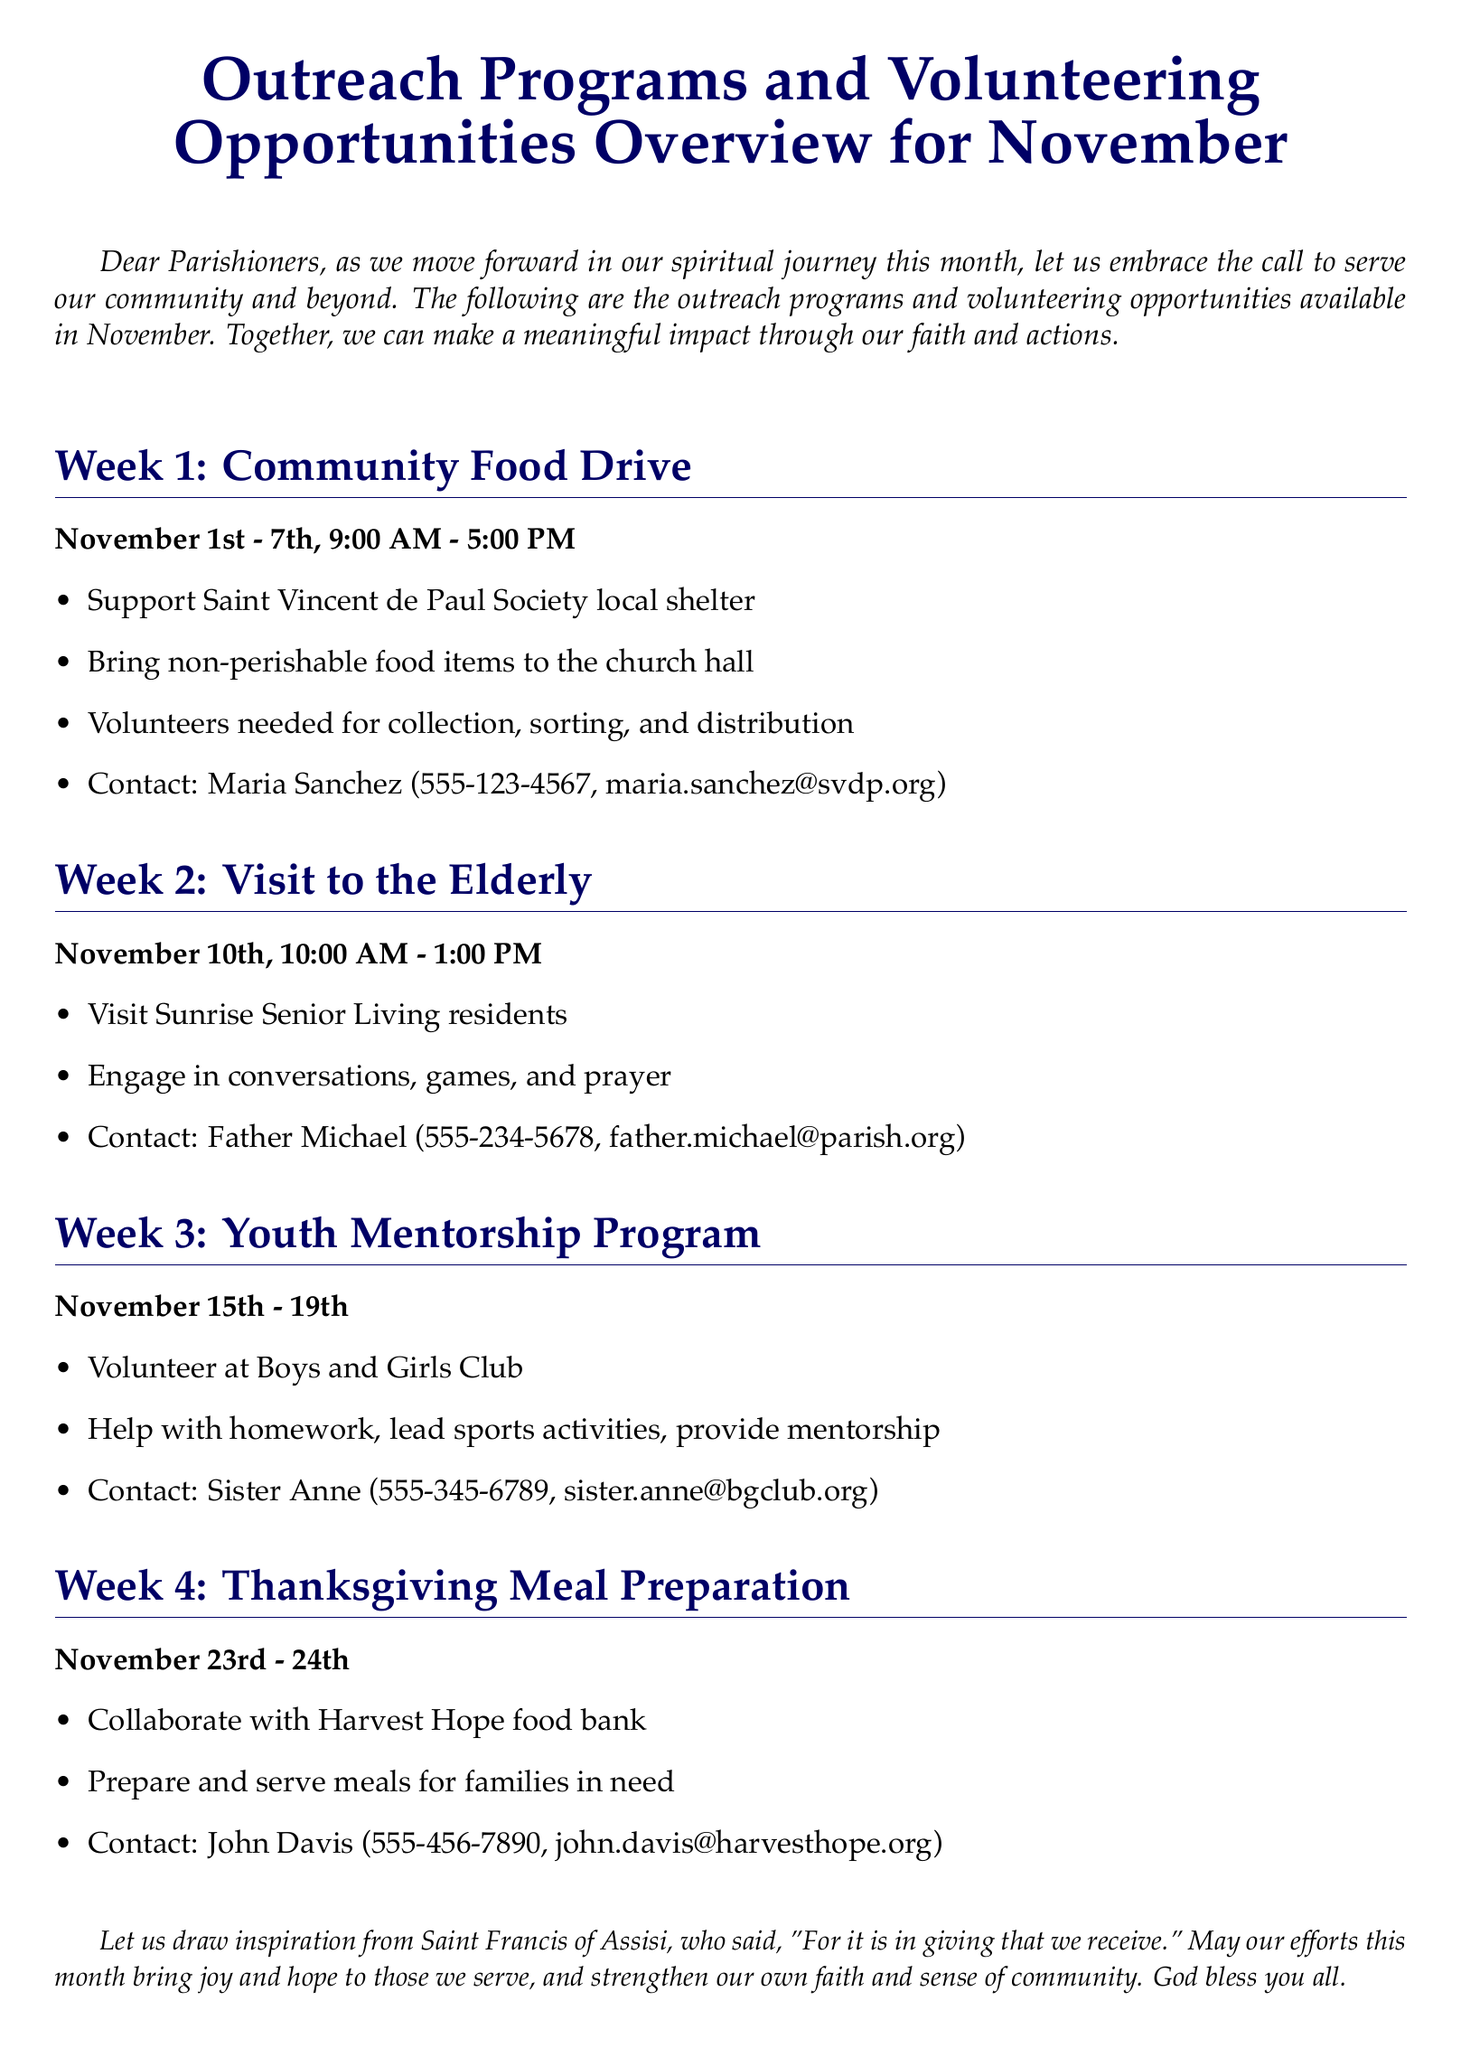What is the duration of the Community Food Drive? The duration is specified as November 1st - 7th.
Answer: November 1st - 7th Who should be contacted for the Thanksgiving Meal Preparation? The contact person for the Thanksgiving Meal Preparation is listed in the document.
Answer: John Davis What time does the Visit to the Elderly start? The starting time for the Visit to the Elderly is mentioned in the schedule.
Answer: 10:00 AM How many days does the Youth Mentorship Program span? The span of the Youth Mentorship Program is defined in the document.
Answer: 5 days What organization is involved in the Community Food Drive? The organization assisting with the Community Food Drive is specified.
Answer: Saint Vincent de Paul Society During which week will the Thanksgiving Meal Preparation occur? The week for Thanksgiving Meal Preparation is indicated in the overview.
Answer: Week 4 What activities are included during the visit to Sunrise Senior Living? The document details the activities planned for the visit.
Answer: Conversations, games, and prayer Which food bank is collaborating for the meal preparation? The collaborating food bank for the meal preparation is referenced in the document.
Answer: Harvest Hope 